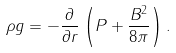Convert formula to latex. <formula><loc_0><loc_0><loc_500><loc_500>\rho g = - \frac { \partial } { \partial r } \left ( P + \frac { B ^ { 2 } } { 8 \pi } \right ) .</formula> 